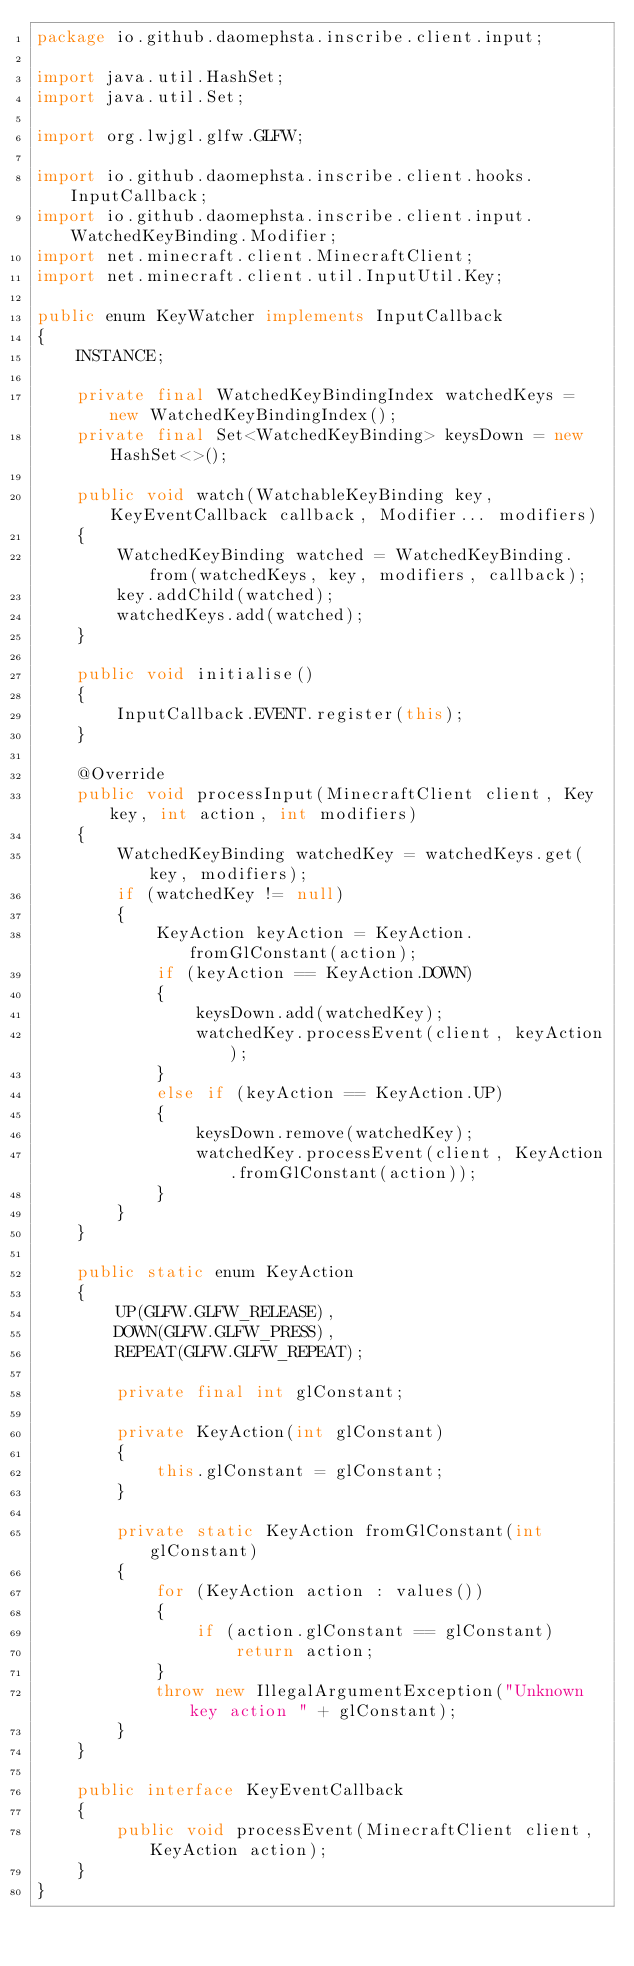Convert code to text. <code><loc_0><loc_0><loc_500><loc_500><_Java_>package io.github.daomephsta.inscribe.client.input;

import java.util.HashSet;
import java.util.Set;

import org.lwjgl.glfw.GLFW;

import io.github.daomephsta.inscribe.client.hooks.InputCallback;
import io.github.daomephsta.inscribe.client.input.WatchedKeyBinding.Modifier;
import net.minecraft.client.MinecraftClient;
import net.minecraft.client.util.InputUtil.Key;

public enum KeyWatcher implements InputCallback
{
    INSTANCE;

    private final WatchedKeyBindingIndex watchedKeys = new WatchedKeyBindingIndex();
    private final Set<WatchedKeyBinding> keysDown = new HashSet<>();

    public void watch(WatchableKeyBinding key, KeyEventCallback callback, Modifier... modifiers)
    {
        WatchedKeyBinding watched = WatchedKeyBinding.from(watchedKeys, key, modifiers, callback);
        key.addChild(watched);
        watchedKeys.add(watched);
    }

    public void initialise()
    {
        InputCallback.EVENT.register(this);
    }

    @Override
    public void processInput(MinecraftClient client, Key key, int action, int modifiers)
    {
        WatchedKeyBinding watchedKey = watchedKeys.get(key, modifiers);
        if (watchedKey != null)
        {
            KeyAction keyAction = KeyAction.fromGlConstant(action);
            if (keyAction == KeyAction.DOWN)
            {
                keysDown.add(watchedKey);
                watchedKey.processEvent(client, keyAction);
            }
            else if (keyAction == KeyAction.UP)
            {
                keysDown.remove(watchedKey);
                watchedKey.processEvent(client, KeyAction.fromGlConstant(action));
            }
        }
    }

    public static enum KeyAction
    {
        UP(GLFW.GLFW_RELEASE),
        DOWN(GLFW.GLFW_PRESS),
        REPEAT(GLFW.GLFW_REPEAT);

        private final int glConstant;

        private KeyAction(int glConstant)
        {
            this.glConstant = glConstant;
        }

        private static KeyAction fromGlConstant(int glConstant)
        {
            for (KeyAction action : values())
            {
                if (action.glConstant == glConstant)
                    return action;
            }
            throw new IllegalArgumentException("Unknown key action " + glConstant);
        }
    }

    public interface KeyEventCallback
    {
        public void processEvent(MinecraftClient client, KeyAction action);
    }
}
</code> 